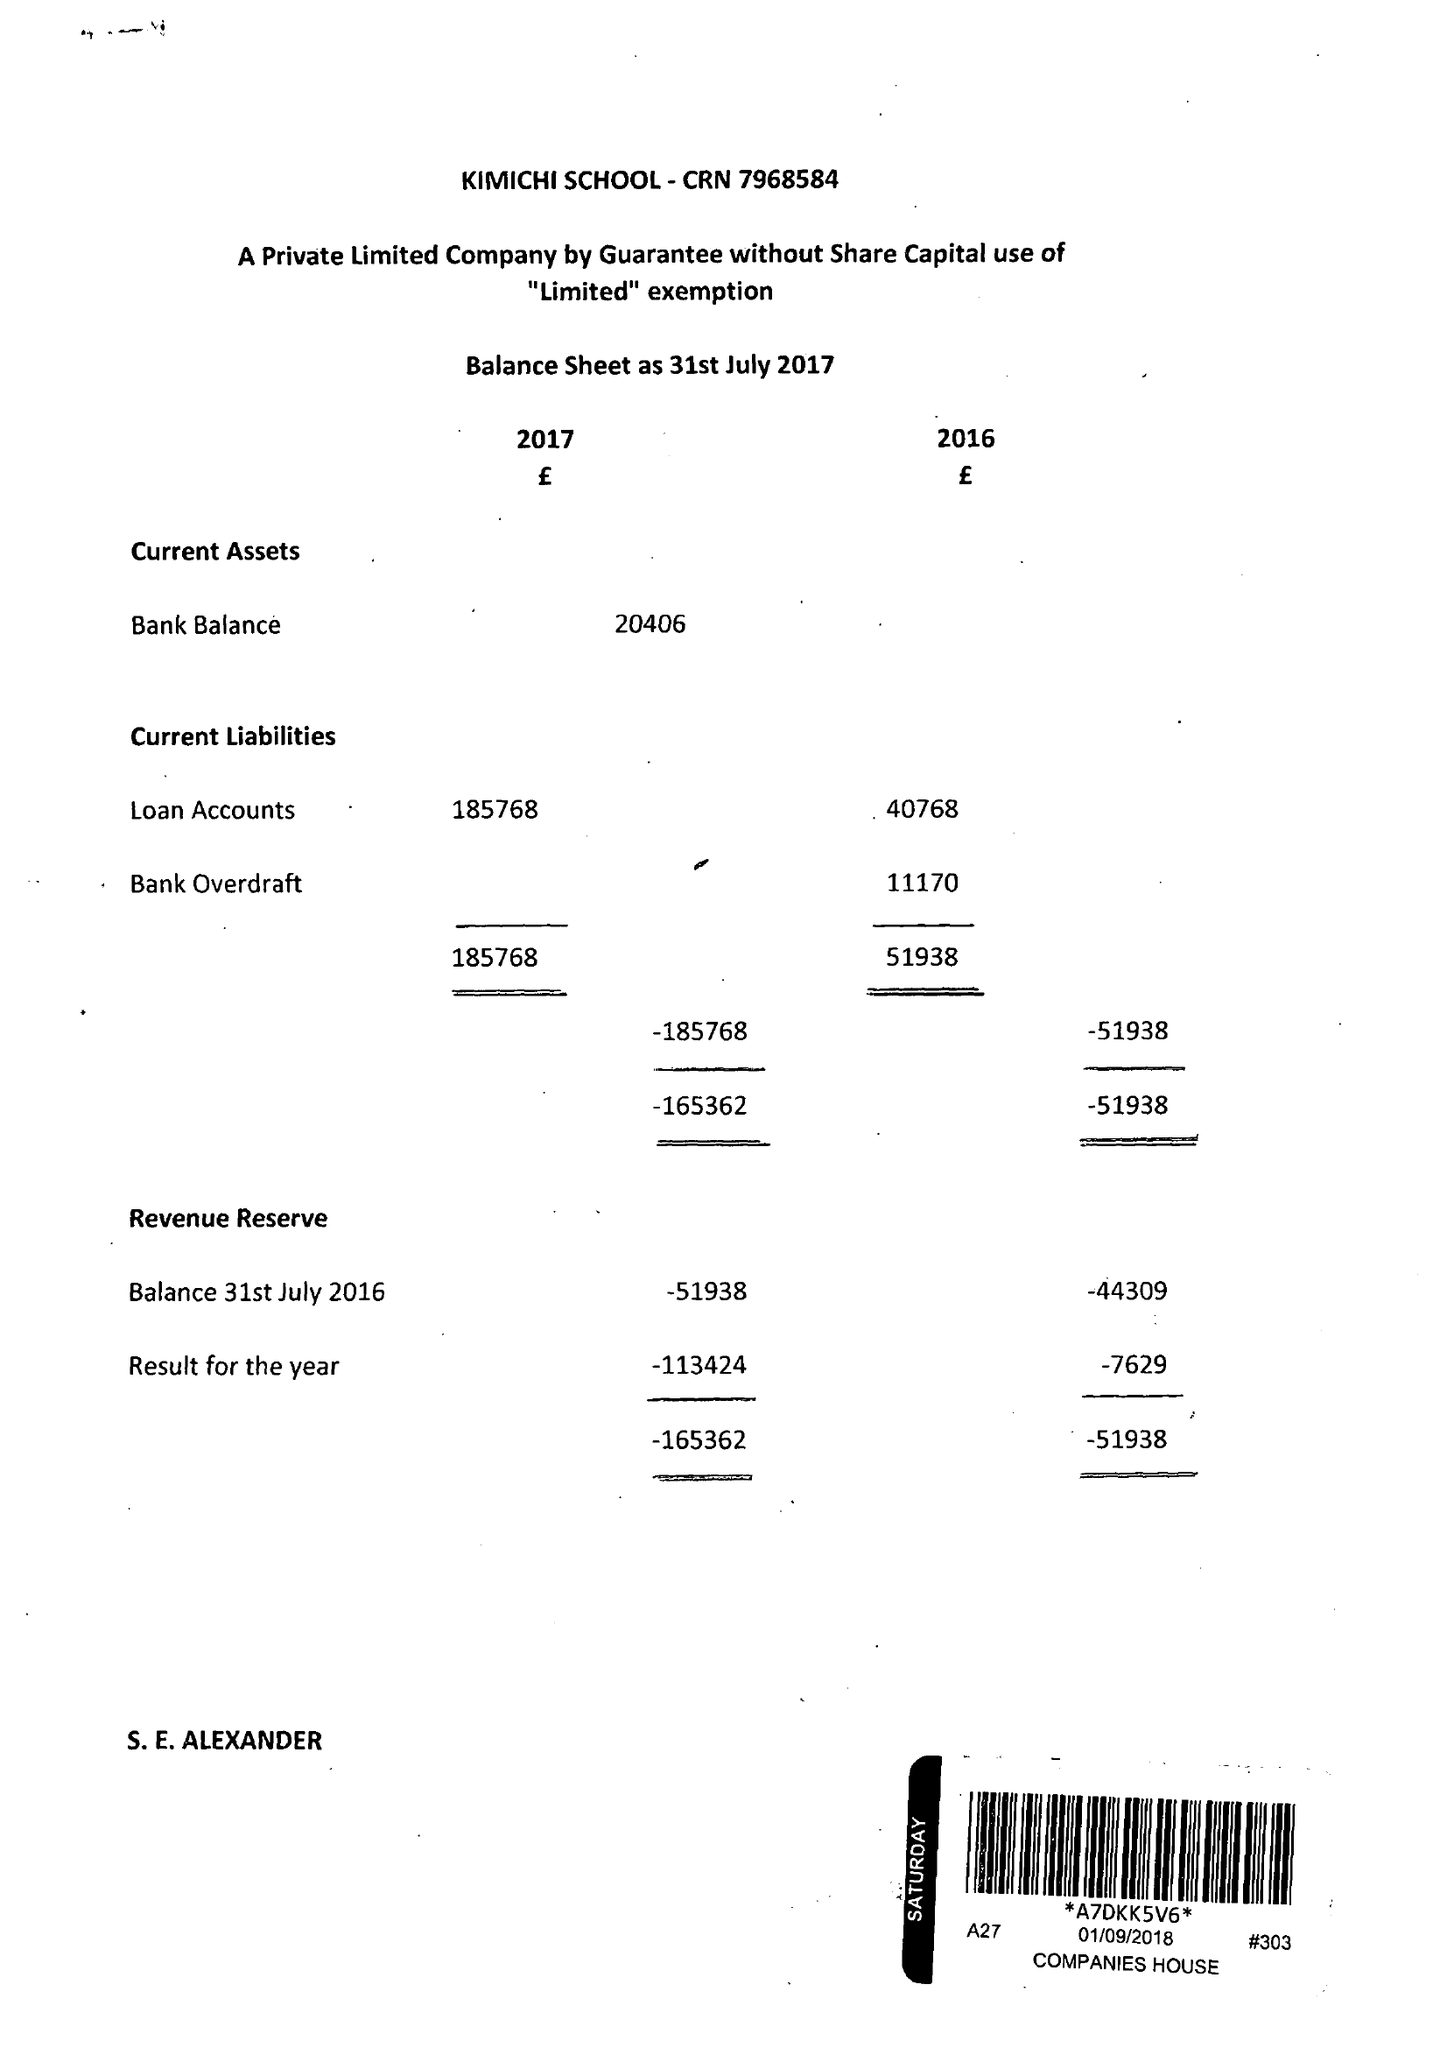What is the value for the address__street_line?
Answer the question using a single word or phrase. 111 YARDLEY ROAD 